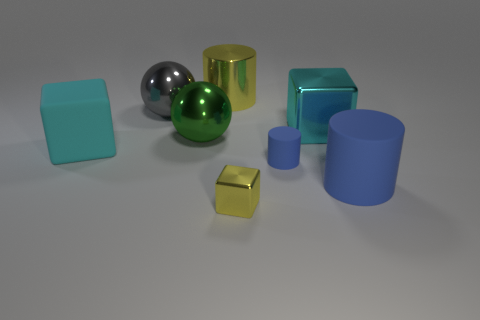The object that is the same color as the big matte cube is what size?
Provide a succinct answer. Large. Are there any other things that have the same size as the cyan metallic block?
Keep it short and to the point. Yes. Is the big blue cylinder made of the same material as the gray ball?
Ensure brevity in your answer.  No. How many objects are cyan blocks to the right of the big gray metallic thing or big objects right of the shiny cylinder?
Give a very brief answer. 2. Is there a blue rubber thing of the same size as the green object?
Your response must be concise. Yes. The other large rubber thing that is the same shape as the large yellow thing is what color?
Keep it short and to the point. Blue. Is there a large cube to the right of the yellow metallic object on the left side of the small yellow thing?
Ensure brevity in your answer.  Yes. There is a big matte thing left of the tiny metal cube; is its shape the same as the green shiny object?
Give a very brief answer. No. What shape is the gray thing?
Provide a succinct answer. Sphere. How many tiny yellow things are the same material as the big green thing?
Ensure brevity in your answer.  1. 